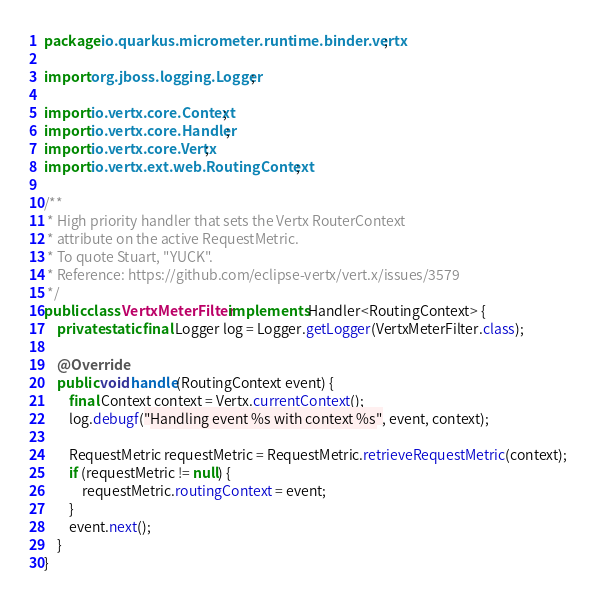Convert code to text. <code><loc_0><loc_0><loc_500><loc_500><_Java_>package io.quarkus.micrometer.runtime.binder.vertx;

import org.jboss.logging.Logger;

import io.vertx.core.Context;
import io.vertx.core.Handler;
import io.vertx.core.Vertx;
import io.vertx.ext.web.RoutingContext;

/**
 * High priority handler that sets the Vertx RouterContext
 * attribute on the active RequestMetric.
 * To quote Stuart, "YUCK".
 * Reference: https://github.com/eclipse-vertx/vert.x/issues/3579
 */
public class VertxMeterFilter implements Handler<RoutingContext> {
    private static final Logger log = Logger.getLogger(VertxMeterFilter.class);

    @Override
    public void handle(RoutingContext event) {
        final Context context = Vertx.currentContext();
        log.debugf("Handling event %s with context %s", event, context);

        RequestMetric requestMetric = RequestMetric.retrieveRequestMetric(context);
        if (requestMetric != null) {
            requestMetric.routingContext = event;
        }
        event.next();
    }
}
</code> 